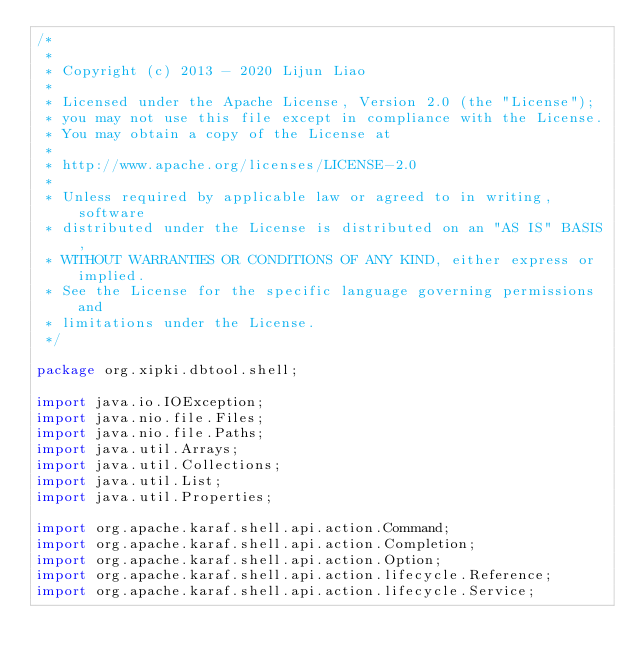<code> <loc_0><loc_0><loc_500><loc_500><_Java_>/*
 *
 * Copyright (c) 2013 - 2020 Lijun Liao
 *
 * Licensed under the Apache License, Version 2.0 (the "License");
 * you may not use this file except in compliance with the License.
 * You may obtain a copy of the License at
 *
 * http://www.apache.org/licenses/LICENSE-2.0
 *
 * Unless required by applicable law or agreed to in writing, software
 * distributed under the License is distributed on an "AS IS" BASIS,
 * WITHOUT WARRANTIES OR CONDITIONS OF ANY KIND, either express or implied.
 * See the License for the specific language governing permissions and
 * limitations under the License.
 */

package org.xipki.dbtool.shell;

import java.io.IOException;
import java.nio.file.Files;
import java.nio.file.Paths;
import java.util.Arrays;
import java.util.Collections;
import java.util.List;
import java.util.Properties;

import org.apache.karaf.shell.api.action.Command;
import org.apache.karaf.shell.api.action.Completion;
import org.apache.karaf.shell.api.action.Option;
import org.apache.karaf.shell.api.action.lifecycle.Reference;
import org.apache.karaf.shell.api.action.lifecycle.Service;</code> 